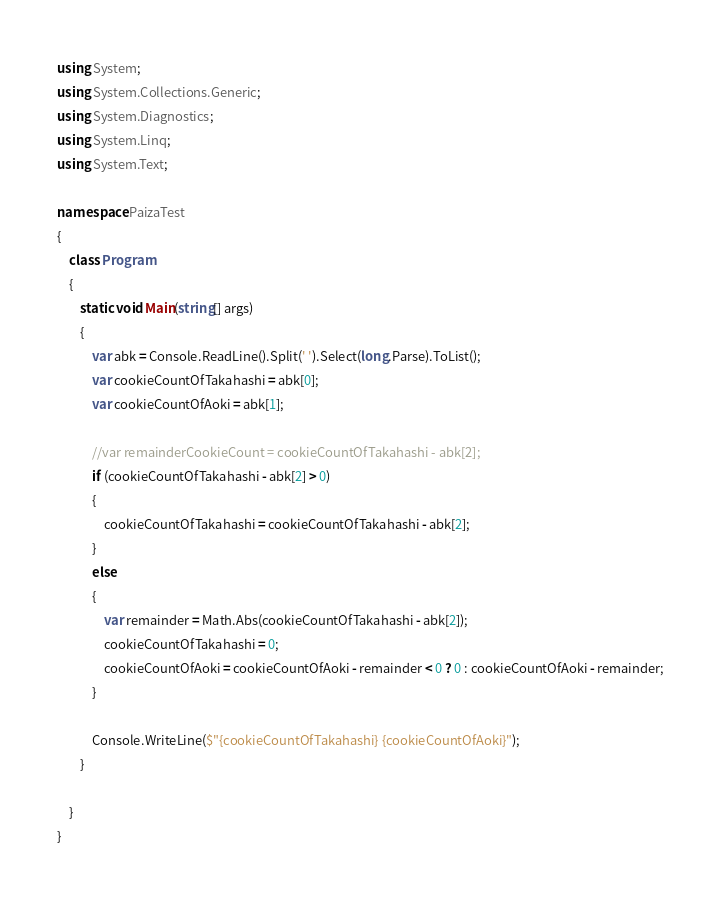Convert code to text. <code><loc_0><loc_0><loc_500><loc_500><_C#_>using System;
using System.Collections.Generic;
using System.Diagnostics;
using System.Linq;
using System.Text;

namespace PaizaTest
{
    class Program
    {
        static void Main(string[] args)
        {
            var abk = Console.ReadLine().Split(' ').Select(long.Parse).ToList();
            var cookieCountOfTakahashi = abk[0];
            var cookieCountOfAoki = abk[1];

            //var remainderCookieCount = cookieCountOfTakahashi - abk[2];
            if (cookieCountOfTakahashi - abk[2] > 0)
            {
                cookieCountOfTakahashi = cookieCountOfTakahashi - abk[2];
            }
            else
            {
                var remainder = Math.Abs(cookieCountOfTakahashi - abk[2]);
                cookieCountOfTakahashi = 0;
                cookieCountOfAoki = cookieCountOfAoki - remainder < 0 ? 0 : cookieCountOfAoki - remainder;
            }

            Console.WriteLine($"{cookieCountOfTakahashi} {cookieCountOfAoki}");
        }
        
    }
}

</code> 